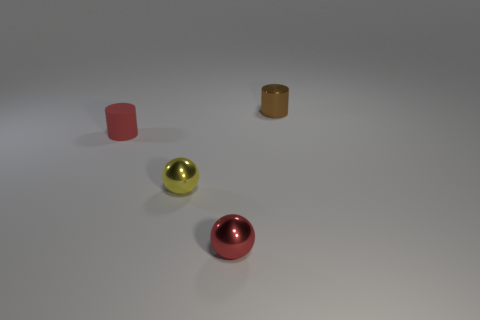There is a red thing behind the small red metallic ball; is it the same shape as the small red metallic thing?
Offer a terse response. No. Is the number of tiny yellow metal objects behind the red cylinder less than the number of red cylinders behind the tiny red shiny sphere?
Ensure brevity in your answer.  Yes. What material is the brown object?
Give a very brief answer. Metal. Does the small rubber cylinder have the same color as the cylinder behind the matte thing?
Provide a succinct answer. No. There is a tiny red rubber object; how many things are behind it?
Provide a succinct answer. 1. Are there fewer metallic cylinders that are in front of the red metal ball than cylinders?
Keep it short and to the point. Yes. What color is the small shiny cylinder?
Make the answer very short. Brown. There is a cylinder that is in front of the small brown thing; is it the same color as the small metal cylinder?
Offer a very short reply. No. What color is the other tiny metallic thing that is the same shape as the red metallic object?
Give a very brief answer. Yellow. What number of small objects are yellow balls or green balls?
Your response must be concise. 1. 